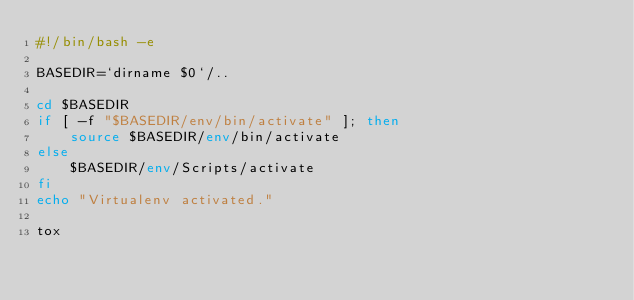Convert code to text. <code><loc_0><loc_0><loc_500><loc_500><_Bash_>#!/bin/bash -e

BASEDIR=`dirname $0`/..

cd $BASEDIR
if [ -f "$BASEDIR/env/bin/activate" ]; then
	source $BASEDIR/env/bin/activate
else
	$BASEDIR/env/Scripts/activate
fi
echo "Virtualenv activated."

tox
</code> 